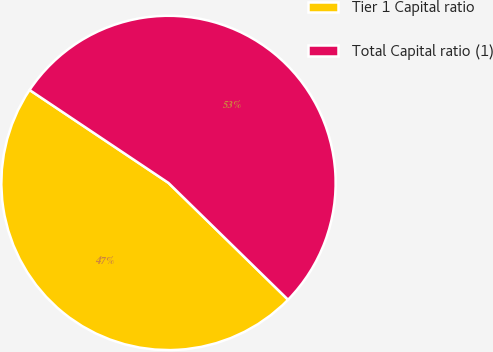<chart> <loc_0><loc_0><loc_500><loc_500><pie_chart><fcel>Tier 1 Capital ratio<fcel>Total Capital ratio (1)<nl><fcel>47.07%<fcel>52.93%<nl></chart> 